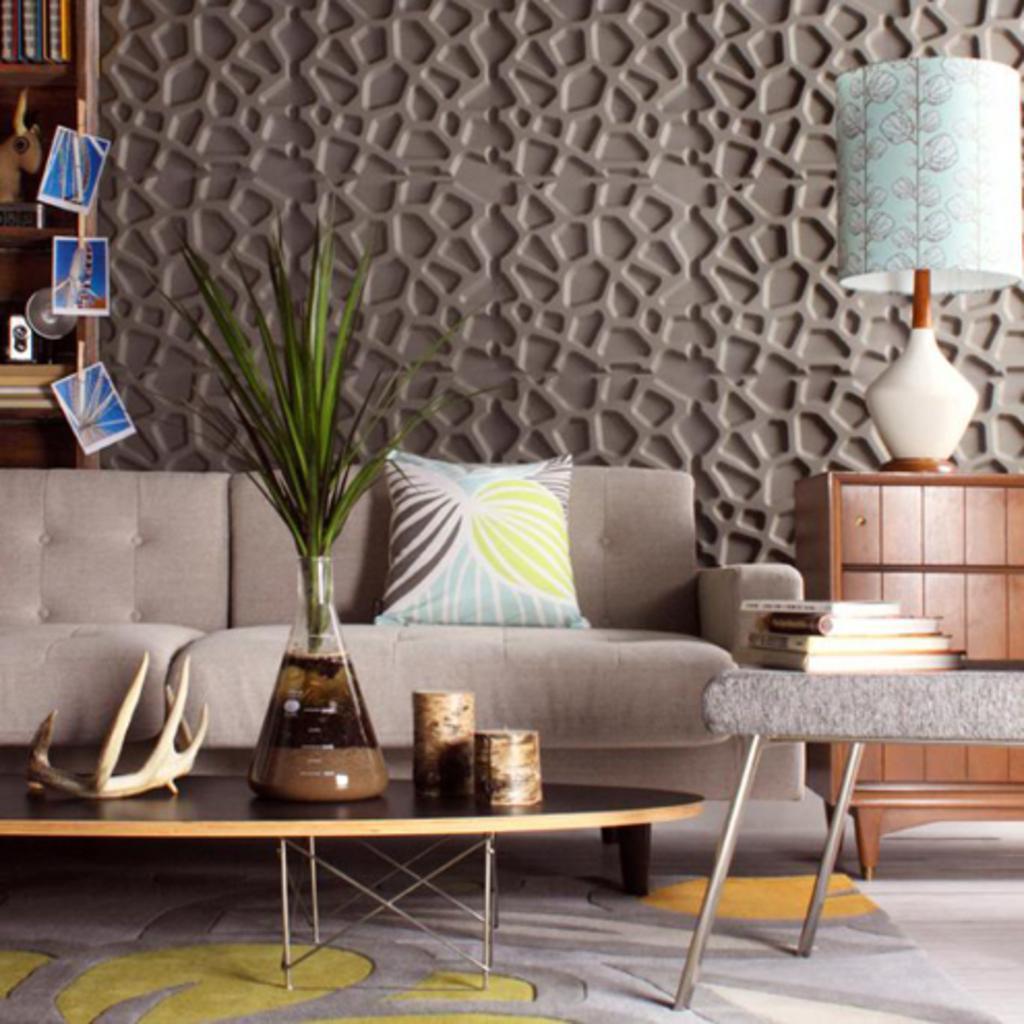Could you give a brief overview of what you see in this image? In the image we can see table,on table there is a flower vase,two mugs. And on the right there is a table,books cupboard and lamp. In the background there is a shelf,wall,couch and pillow. 